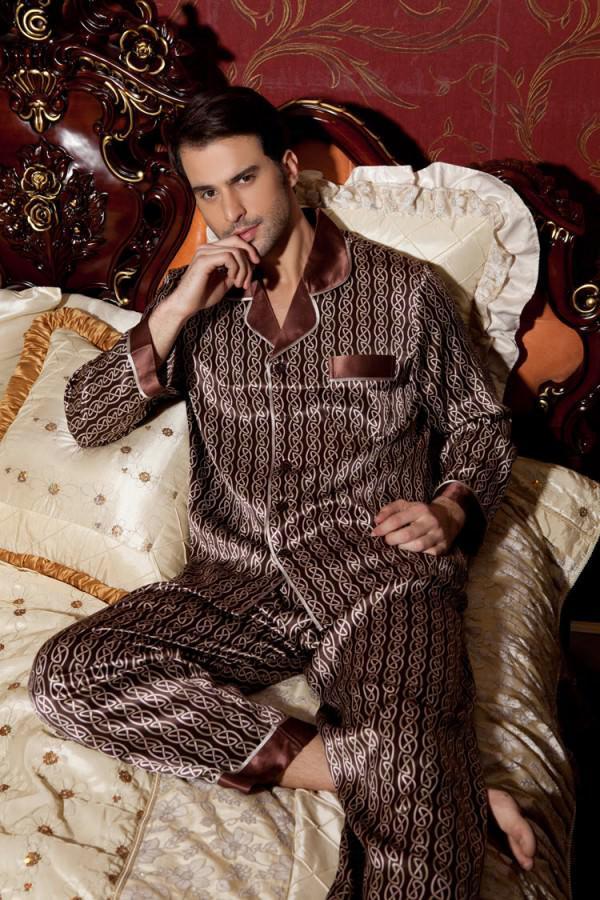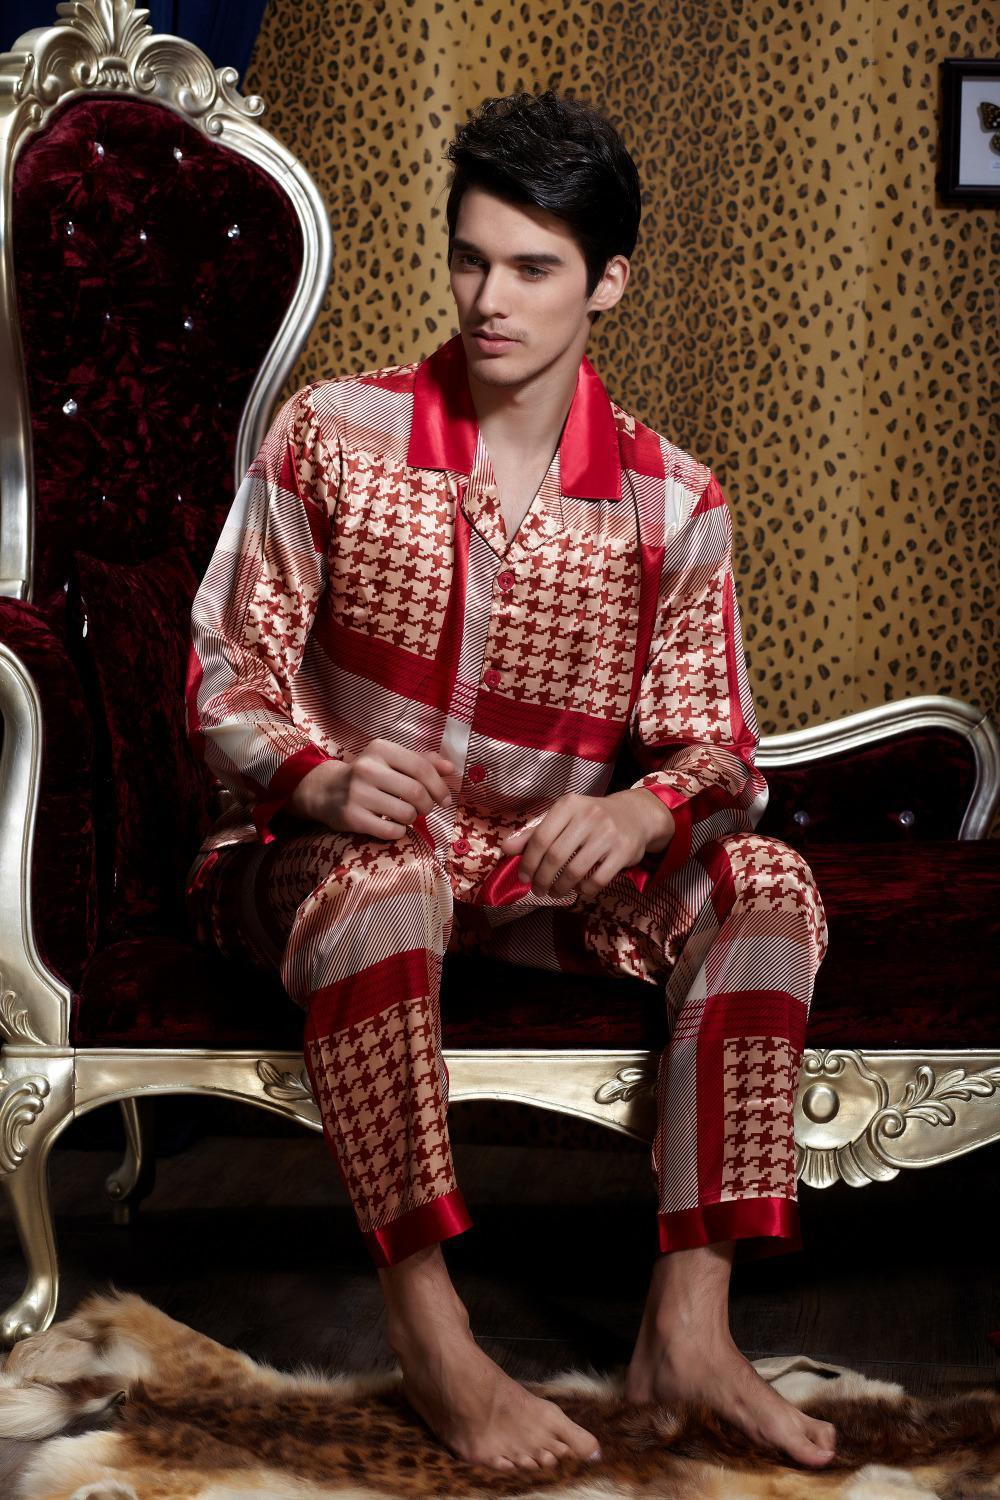The first image is the image on the left, the second image is the image on the right. For the images displayed, is the sentence "the man is holding something in his hands in the right pic" factually correct? Answer yes or no. No. The first image is the image on the left, the second image is the image on the right. For the images shown, is this caption "In one of the images, a man is wearing checkered pajamas." true? Answer yes or no. Yes. 